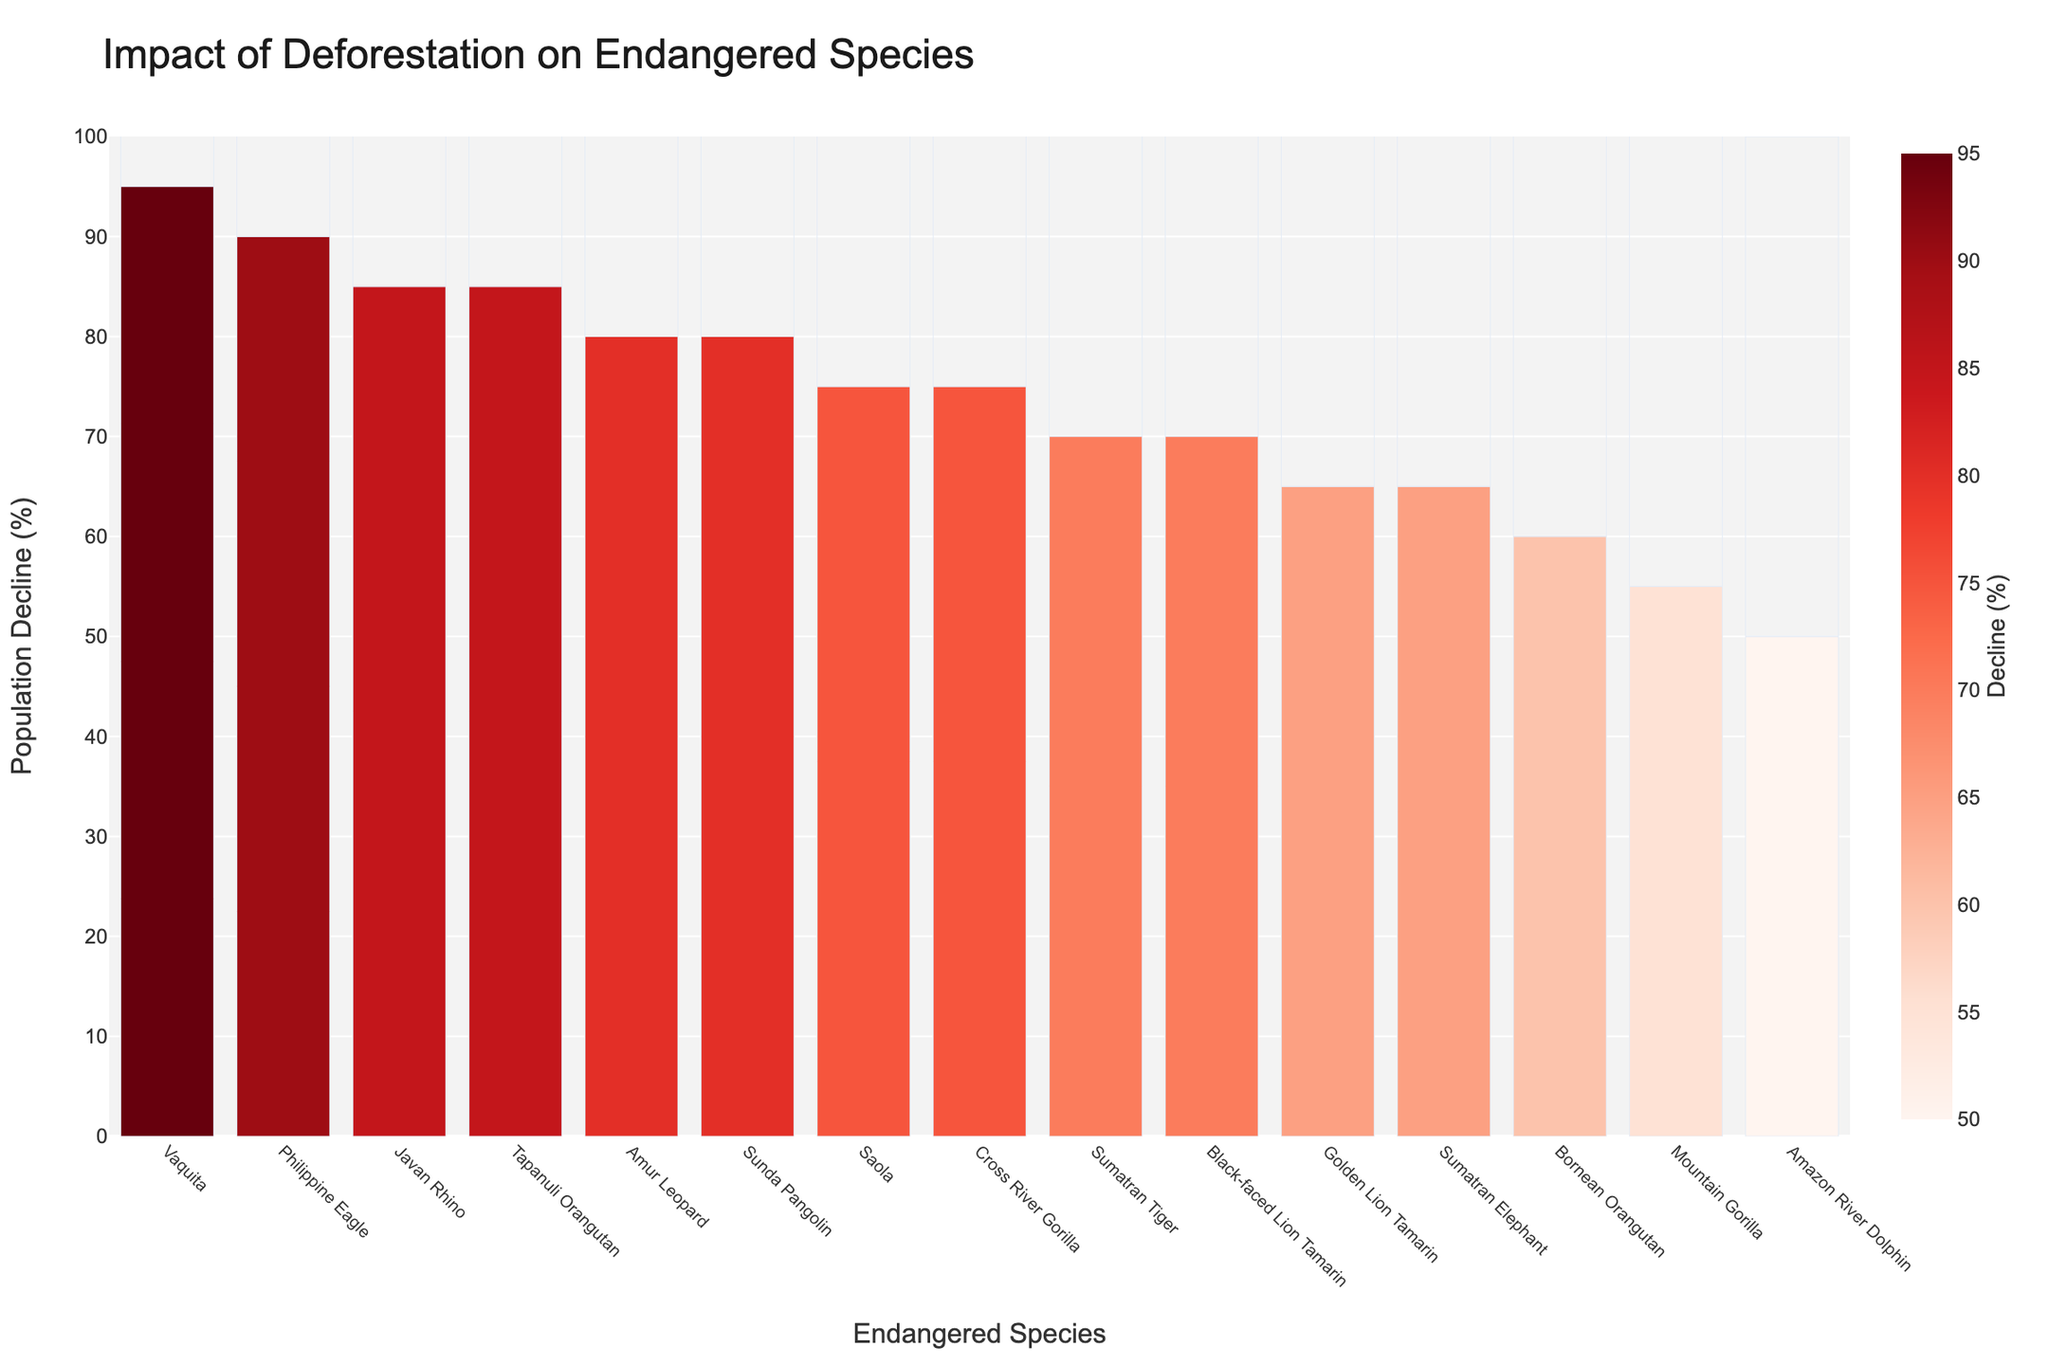What species has the highest population decline according to the chart? The species with the highest bar and the darkest color on the chart represents the highest population decline. From the chart, it is the Vaquita, with a decline of 95%.
Answer: Vaquita Which species has a higher population decline: the Sumatran Tiger or the Mountain Gorilla? By comparing the height of the bars labeled 'Sumatran Tiger' and 'Mountain Gorilla,' the Sumatran Tiger shows a 70% decline, whereas the Mountain Gorilla shows a 55% decline. Thus, the Sumatran Tiger has a higher decline.
Answer: Sumatran Tiger What is the median value of population decline among all species? To find the median, we need to list all the decline percentages in ascending order and find the middle value. The sorted values are: 50, 55, 60, 65, 65, 70, 70, 75, 75, 80, 80, 85, 85, 90, 95. The median is the middle value, which is 75.
Answer: 75 Which species have a population decline of 80% or more? Examining the bars in the chart for those equal to or exceeding 80% population decline, we have the Vaquita (95%), Philippine Eagle (90%), Javan Rhino (85%), Tapanuli Orangutan (85%), Amur Leopard (80%), and Sunda Pangolin (80%).
Answer: Vaquita, Philippine Eagle, Javan Rhino, Tapanuli Orangutan, Amur Leopard, Sunda Pangolin How many species have a population decline between 60% and 70%? By checking the bars with heights between 60% and 70%, we find the Bornean Orangutan (60%), Sumatran Elephant (65%), Golden Lion Tamarin (65%), Black-faced Lion Tamarin (70%), and Sumatran Tiger (70%). Thus, there are 5 species in this range.
Answer: 5 What is the average population decline for species with a decline of 75%? The values for this group are Cross River Gorilla and Saola. 75% each. The average decline is calculated as (75 + 75) / 2 = 75.
Answer: 75 Which species has the lowest population decline, and what is the percentage? The species with the shortest bar and the lightest color represents the lowest population decline. From the chart, it is the Amazon River Dolphin, with a decline of 50%.
Answer: Amazon River Dolphin, 50% What is the combined population decline percentage for all species listed? Summing up all the population decline percentages: 70 + 60 + 85 + 55 + 50 + 65 + 80 + 75 + 95 + 90 + 80 + 70 + 85 + 65 + 75 = 1090.
Answer: 1090 What range of colors represents the highest population declines on the chart? The darkest colors on the color scale represent the highest population declines, indicating the most extreme percentage declines are visually marked by dark shades of red.
Answer: Dark shades of red Compare the population decline between the Javan Rhino and the Tapanuli Orangutan. Which one has a greater decline? Both the Javan Rhino and the Tapanuli Orangutan have bars that are of the same height, showing an equal population decline of 85%.
Answer: They both have an equal decline 